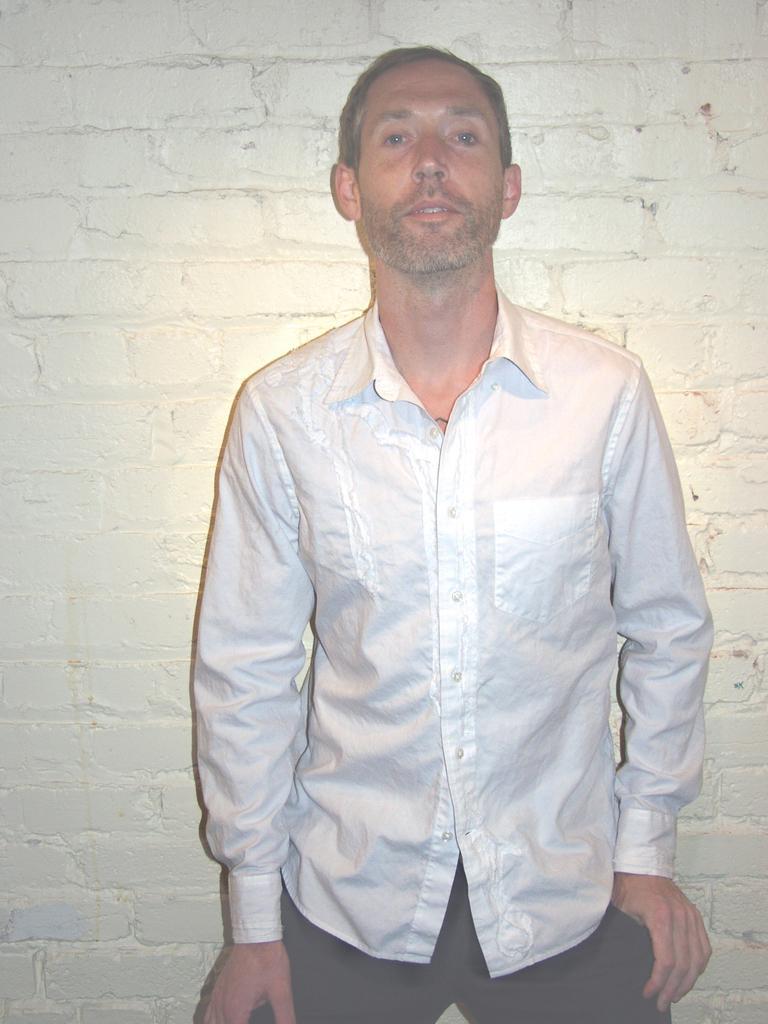Could you give a brief overview of what you see in this image? In this image I can see a person standing and wearing white and black dress. I can see a white wall. 